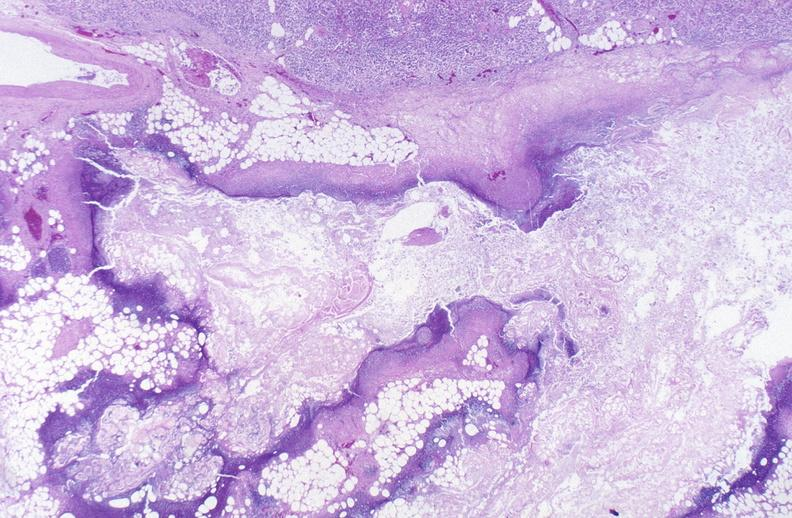does this image show pancreatic fat necrosis?
Answer the question using a single word or phrase. Yes 